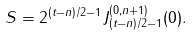Convert formula to latex. <formula><loc_0><loc_0><loc_500><loc_500>S = 2 ^ { ( t - n ) / 2 - 1 } J _ { ( t - n ) / 2 - 1 } ^ { ( 0 , n + 1 ) } ( 0 ) .</formula> 